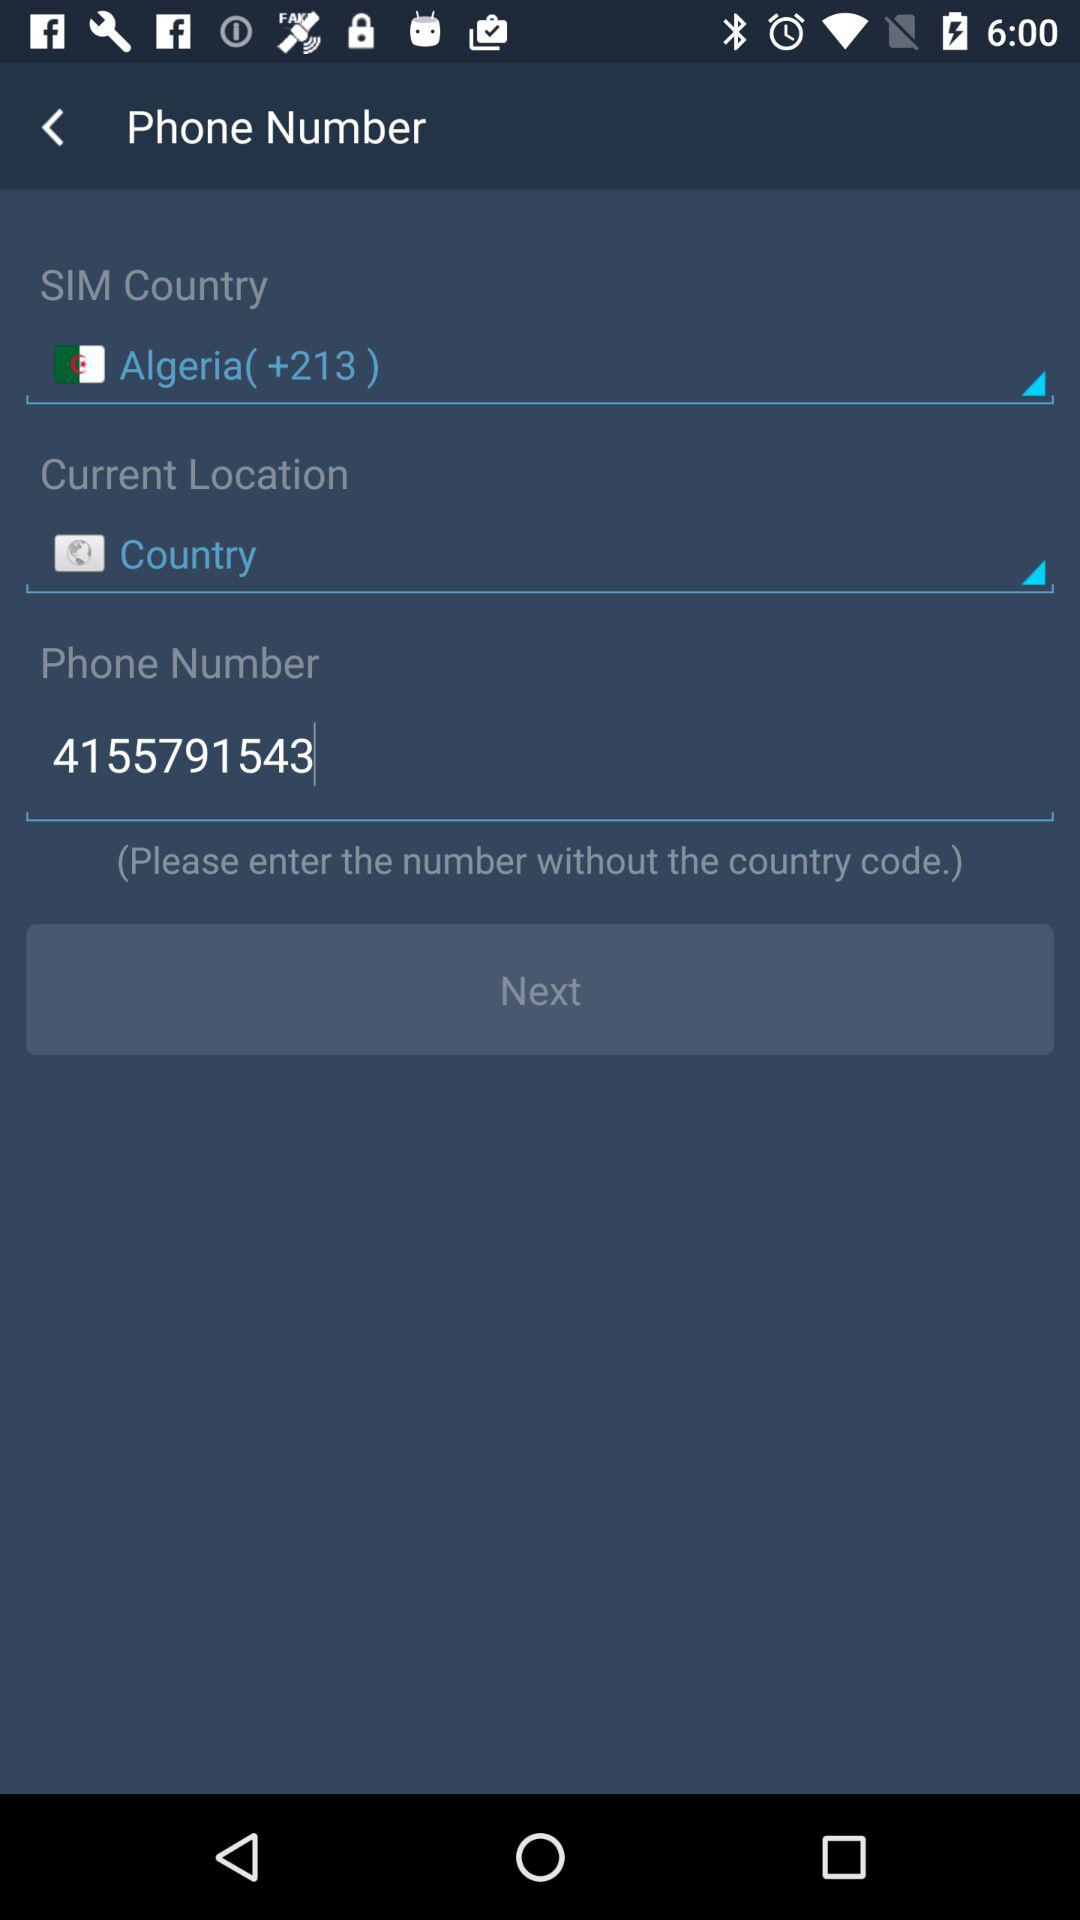What is the given phone number? The given phone number is 4155791543. 